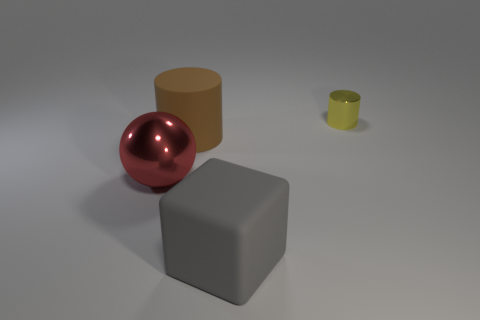Add 4 purple rubber cubes. How many objects exist? 8 Subtract all big purple cylinders. Subtract all brown objects. How many objects are left? 3 Add 4 small metal cylinders. How many small metal cylinders are left? 5 Add 4 small gray rubber things. How many small gray rubber things exist? 4 Subtract all yellow cylinders. How many cylinders are left? 1 Subtract 0 brown blocks. How many objects are left? 4 Subtract all yellow cubes. Subtract all cyan spheres. How many cubes are left? 1 Subtract all blue spheres. How many brown blocks are left? 0 